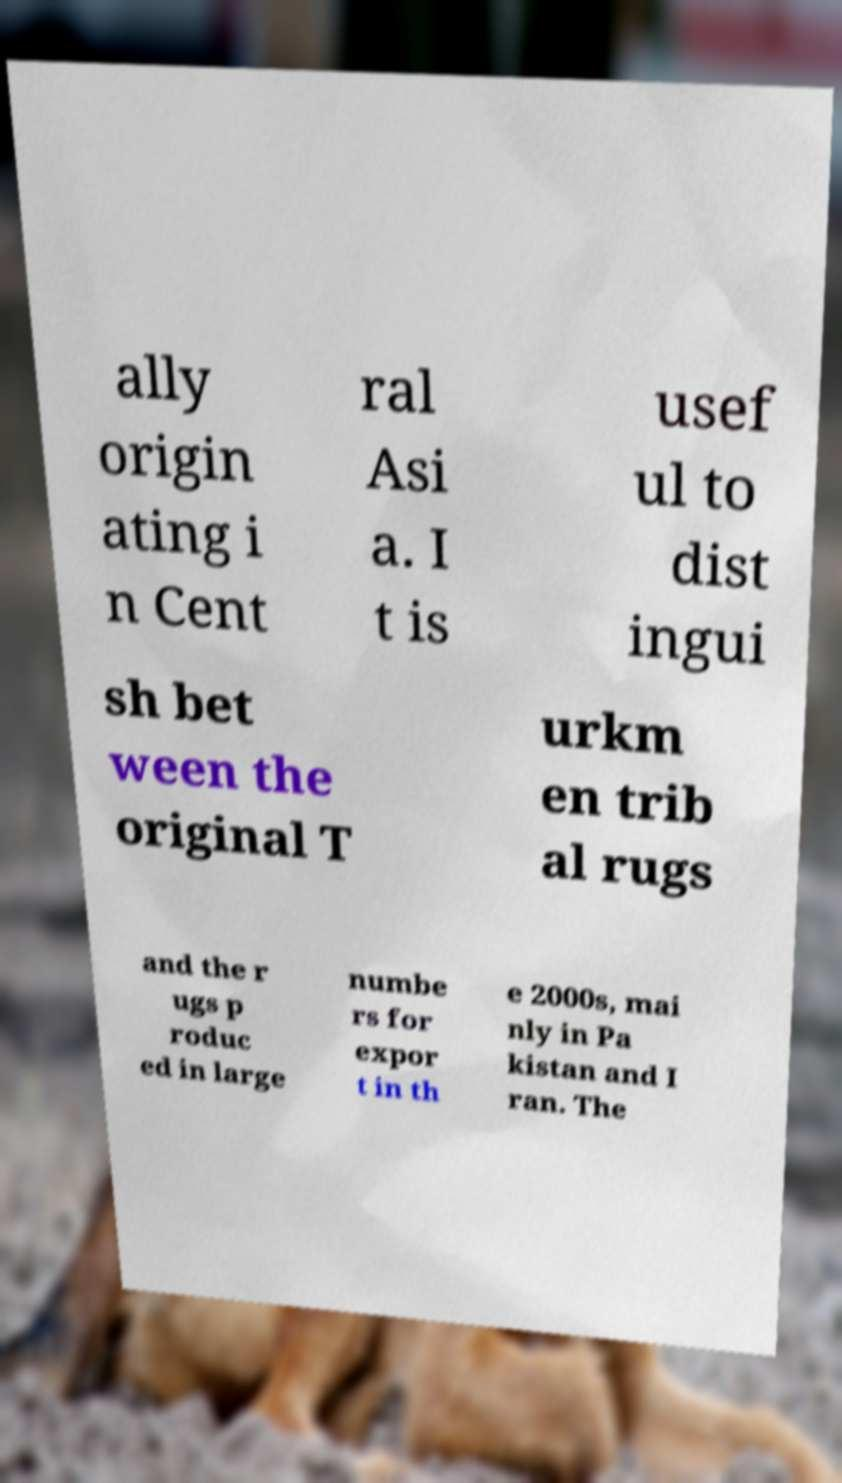Can you read and provide the text displayed in the image?This photo seems to have some interesting text. Can you extract and type it out for me? ally origin ating i n Cent ral Asi a. I t is usef ul to dist ingui sh bet ween the original T urkm en trib al rugs and the r ugs p roduc ed in large numbe rs for expor t in th e 2000s, mai nly in Pa kistan and I ran. The 